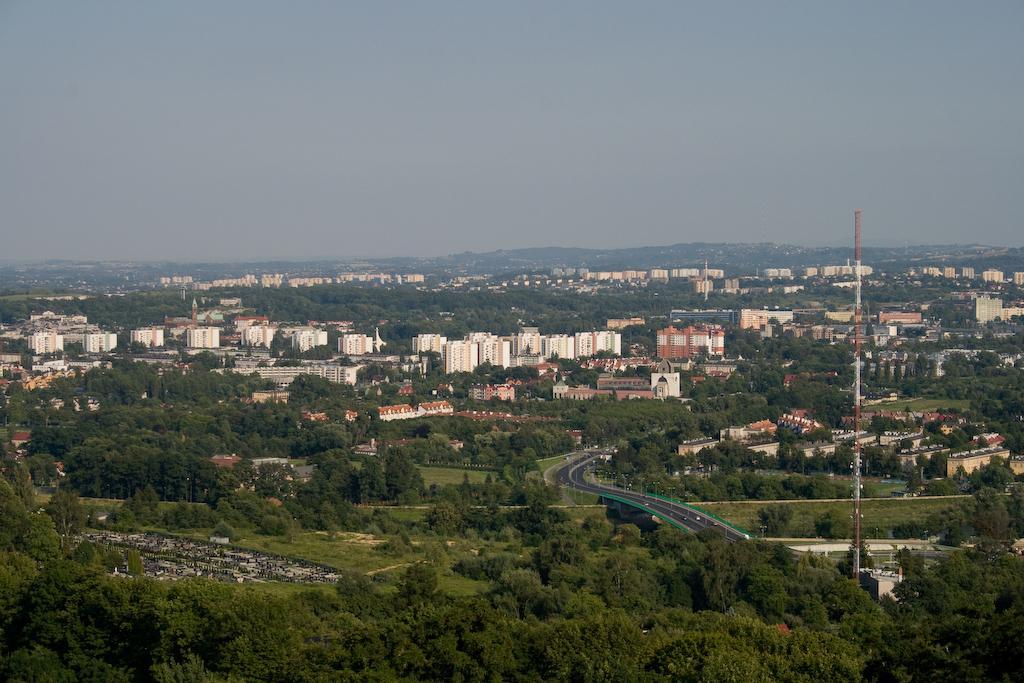In one or two sentences, can you explain what this image depicts? This is an aerial view. In this picture we can see the buildings, trees, bridge, road, vehicles, poles, tower. At the top of the image we can see the sky. 